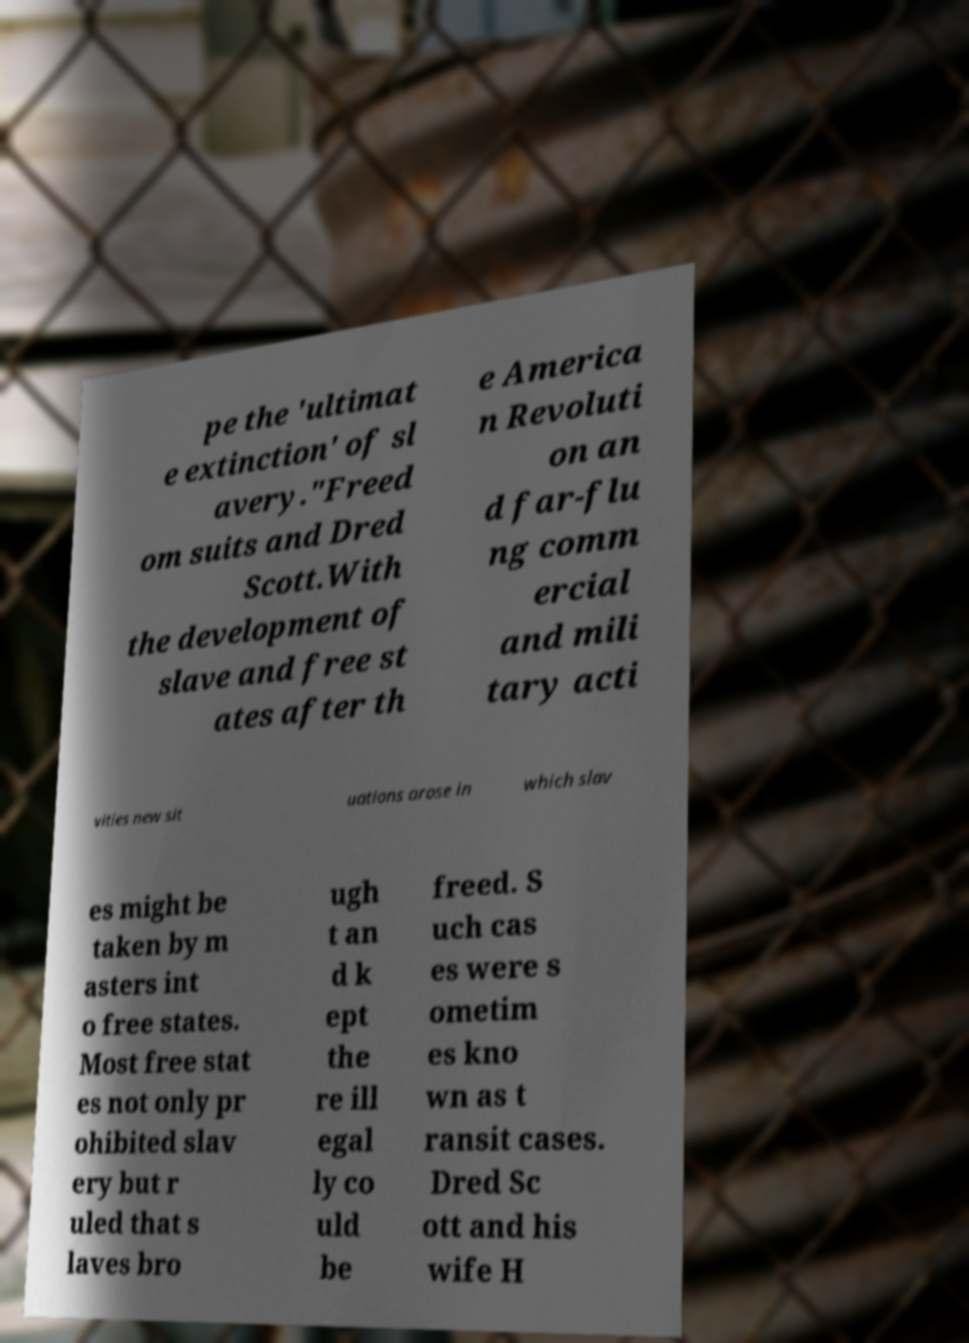Could you extract and type out the text from this image? pe the 'ultimat e extinction' of sl avery."Freed om suits and Dred Scott.With the development of slave and free st ates after th e America n Revoluti on an d far-flu ng comm ercial and mili tary acti vities new sit uations arose in which slav es might be taken by m asters int o free states. Most free stat es not only pr ohibited slav ery but r uled that s laves bro ugh t an d k ept the re ill egal ly co uld be freed. S uch cas es were s ometim es kno wn as t ransit cases. Dred Sc ott and his wife H 